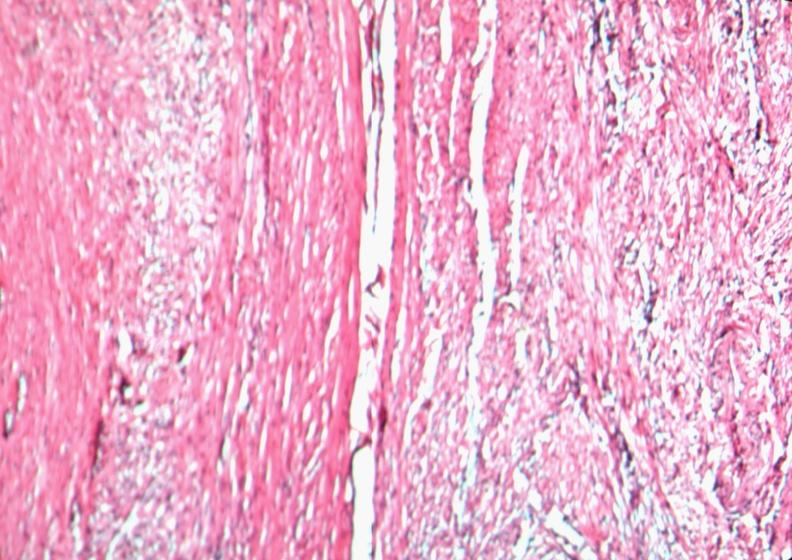where is this from?
Answer the question using a single word or phrase. Female reproductive system 